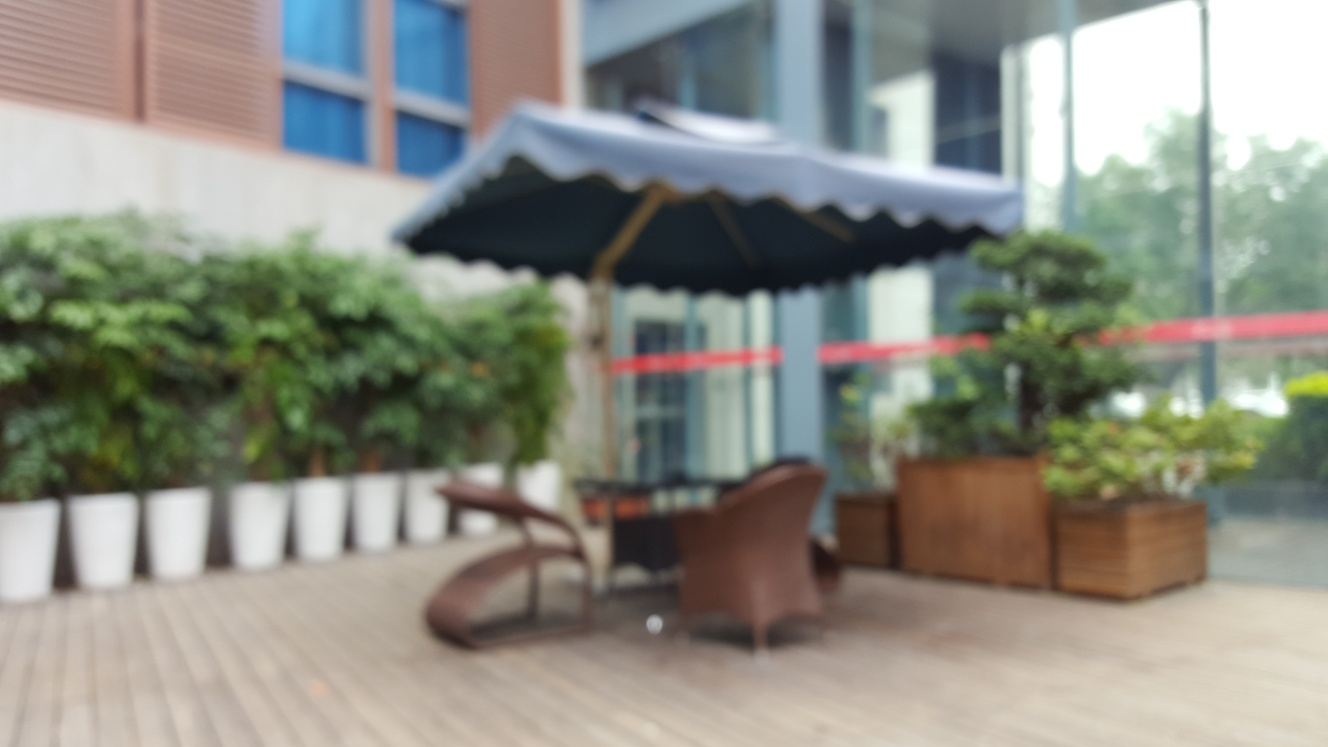Is the main subject positioned prominently in the center of the frame? Although the image is blurred and the exact details are difficult to discern, the structure of the scene suggests that the primary subject, which appears to be outdoor seating under an umbrella, is indeed positioned centrally. However, the lack of sharp focus makes it challenging to ascertain prominent positioning definitively. Typically, a prominently positioned subject would be in clear focus to draw the viewer's attention. 